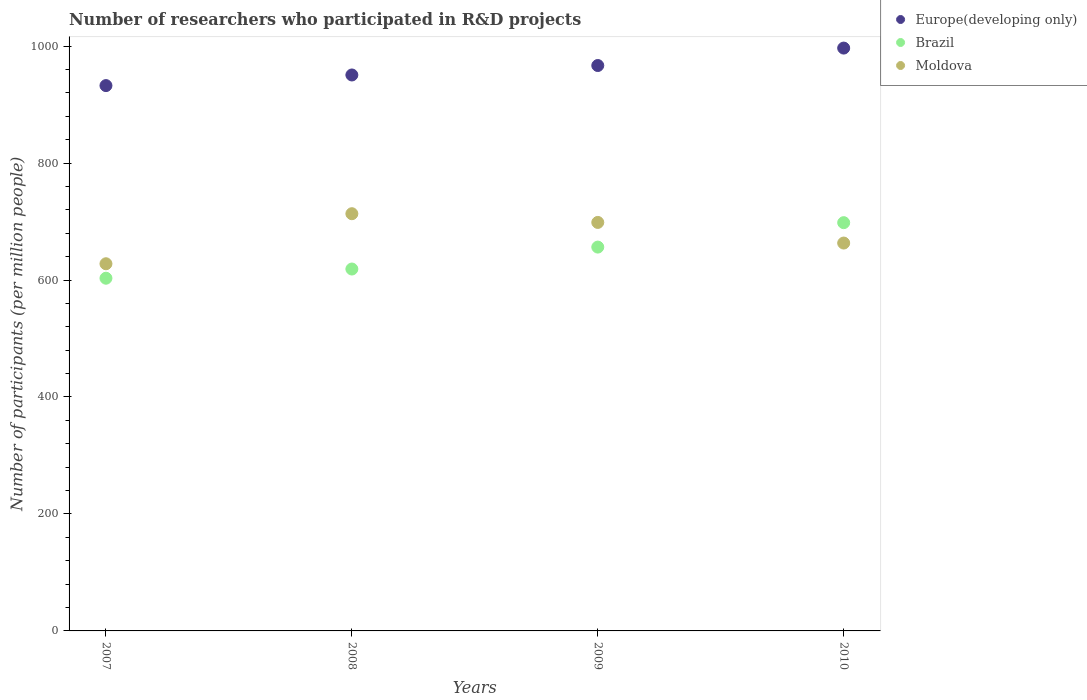How many different coloured dotlines are there?
Offer a terse response. 3. What is the number of researchers who participated in R&D projects in Europe(developing only) in 2008?
Your answer should be very brief. 950.66. Across all years, what is the maximum number of researchers who participated in R&D projects in Moldova?
Provide a short and direct response. 713.42. Across all years, what is the minimum number of researchers who participated in R&D projects in Europe(developing only)?
Keep it short and to the point. 932.49. In which year was the number of researchers who participated in R&D projects in Brazil maximum?
Keep it short and to the point. 2010. In which year was the number of researchers who participated in R&D projects in Moldova minimum?
Give a very brief answer. 2007. What is the total number of researchers who participated in R&D projects in Brazil in the graph?
Your response must be concise. 2576.37. What is the difference between the number of researchers who participated in R&D projects in Europe(developing only) in 2009 and that in 2010?
Provide a short and direct response. -29.82. What is the difference between the number of researchers who participated in R&D projects in Brazil in 2007 and the number of researchers who participated in R&D projects in Europe(developing only) in 2009?
Offer a terse response. -363.71. What is the average number of researchers who participated in R&D projects in Moldova per year?
Offer a terse response. 675.75. In the year 2008, what is the difference between the number of researchers who participated in R&D projects in Europe(developing only) and number of researchers who participated in R&D projects in Moldova?
Ensure brevity in your answer.  237.24. In how many years, is the number of researchers who participated in R&D projects in Brazil greater than 880?
Provide a succinct answer. 0. What is the ratio of the number of researchers who participated in R&D projects in Moldova in 2007 to that in 2009?
Give a very brief answer. 0.9. Is the number of researchers who participated in R&D projects in Europe(developing only) in 2008 less than that in 2010?
Your answer should be very brief. Yes. What is the difference between the highest and the second highest number of researchers who participated in R&D projects in Moldova?
Provide a succinct answer. 14.9. What is the difference between the highest and the lowest number of researchers who participated in R&D projects in Moldova?
Keep it short and to the point. 85.59. Is the sum of the number of researchers who participated in R&D projects in Europe(developing only) in 2009 and 2010 greater than the maximum number of researchers who participated in R&D projects in Moldova across all years?
Provide a short and direct response. Yes. Is it the case that in every year, the sum of the number of researchers who participated in R&D projects in Brazil and number of researchers who participated in R&D projects in Moldova  is greater than the number of researchers who participated in R&D projects in Europe(developing only)?
Keep it short and to the point. Yes. Does the number of researchers who participated in R&D projects in Moldova monotonically increase over the years?
Provide a succinct answer. No. Is the number of researchers who participated in R&D projects in Moldova strictly less than the number of researchers who participated in R&D projects in Brazil over the years?
Provide a succinct answer. No. How many dotlines are there?
Provide a succinct answer. 3. Are the values on the major ticks of Y-axis written in scientific E-notation?
Ensure brevity in your answer.  No. Does the graph contain grids?
Ensure brevity in your answer.  No. Where does the legend appear in the graph?
Give a very brief answer. Top right. How are the legend labels stacked?
Offer a very short reply. Vertical. What is the title of the graph?
Keep it short and to the point. Number of researchers who participated in R&D projects. Does "Ghana" appear as one of the legend labels in the graph?
Make the answer very short. No. What is the label or title of the X-axis?
Provide a succinct answer. Years. What is the label or title of the Y-axis?
Offer a terse response. Number of participants (per million people). What is the Number of participants (per million people) in Europe(developing only) in 2007?
Offer a very short reply. 932.49. What is the Number of participants (per million people) of Brazil in 2007?
Give a very brief answer. 603.11. What is the Number of participants (per million people) in Moldova in 2007?
Give a very brief answer. 627.84. What is the Number of participants (per million people) in Europe(developing only) in 2008?
Provide a succinct answer. 950.66. What is the Number of participants (per million people) of Brazil in 2008?
Your answer should be very brief. 618.83. What is the Number of participants (per million people) of Moldova in 2008?
Your response must be concise. 713.42. What is the Number of participants (per million people) of Europe(developing only) in 2009?
Make the answer very short. 966.82. What is the Number of participants (per million people) of Brazil in 2009?
Your response must be concise. 656.34. What is the Number of participants (per million people) in Moldova in 2009?
Your answer should be compact. 698.52. What is the Number of participants (per million people) in Europe(developing only) in 2010?
Make the answer very short. 996.64. What is the Number of participants (per million people) of Brazil in 2010?
Your answer should be compact. 698.1. What is the Number of participants (per million people) of Moldova in 2010?
Give a very brief answer. 663.24. Across all years, what is the maximum Number of participants (per million people) in Europe(developing only)?
Provide a succinct answer. 996.64. Across all years, what is the maximum Number of participants (per million people) in Brazil?
Make the answer very short. 698.1. Across all years, what is the maximum Number of participants (per million people) of Moldova?
Provide a succinct answer. 713.42. Across all years, what is the minimum Number of participants (per million people) of Europe(developing only)?
Your answer should be very brief. 932.49. Across all years, what is the minimum Number of participants (per million people) in Brazil?
Give a very brief answer. 603.11. Across all years, what is the minimum Number of participants (per million people) of Moldova?
Your answer should be very brief. 627.84. What is the total Number of participants (per million people) in Europe(developing only) in the graph?
Ensure brevity in your answer.  3846.61. What is the total Number of participants (per million people) in Brazil in the graph?
Offer a very short reply. 2576.37. What is the total Number of participants (per million people) of Moldova in the graph?
Provide a succinct answer. 2703.02. What is the difference between the Number of participants (per million people) of Europe(developing only) in 2007 and that in 2008?
Give a very brief answer. -18.17. What is the difference between the Number of participants (per million people) of Brazil in 2007 and that in 2008?
Offer a very short reply. -15.72. What is the difference between the Number of participants (per million people) in Moldova in 2007 and that in 2008?
Your answer should be compact. -85.59. What is the difference between the Number of participants (per million people) of Europe(developing only) in 2007 and that in 2009?
Give a very brief answer. -34.33. What is the difference between the Number of participants (per million people) in Brazil in 2007 and that in 2009?
Keep it short and to the point. -53.23. What is the difference between the Number of participants (per million people) of Moldova in 2007 and that in 2009?
Keep it short and to the point. -70.68. What is the difference between the Number of participants (per million people) in Europe(developing only) in 2007 and that in 2010?
Provide a succinct answer. -64.15. What is the difference between the Number of participants (per million people) of Brazil in 2007 and that in 2010?
Offer a very short reply. -94.99. What is the difference between the Number of participants (per million people) in Moldova in 2007 and that in 2010?
Offer a very short reply. -35.4. What is the difference between the Number of participants (per million people) in Europe(developing only) in 2008 and that in 2009?
Your response must be concise. -16.16. What is the difference between the Number of participants (per million people) in Brazil in 2008 and that in 2009?
Your response must be concise. -37.51. What is the difference between the Number of participants (per million people) in Moldova in 2008 and that in 2009?
Make the answer very short. 14.9. What is the difference between the Number of participants (per million people) in Europe(developing only) in 2008 and that in 2010?
Provide a succinct answer. -45.98. What is the difference between the Number of participants (per million people) of Brazil in 2008 and that in 2010?
Your answer should be compact. -79.27. What is the difference between the Number of participants (per million people) of Moldova in 2008 and that in 2010?
Make the answer very short. 50.18. What is the difference between the Number of participants (per million people) in Europe(developing only) in 2009 and that in 2010?
Provide a succinct answer. -29.82. What is the difference between the Number of participants (per million people) in Brazil in 2009 and that in 2010?
Keep it short and to the point. -41.77. What is the difference between the Number of participants (per million people) in Moldova in 2009 and that in 2010?
Your answer should be compact. 35.28. What is the difference between the Number of participants (per million people) in Europe(developing only) in 2007 and the Number of participants (per million people) in Brazil in 2008?
Your answer should be very brief. 313.66. What is the difference between the Number of participants (per million people) in Europe(developing only) in 2007 and the Number of participants (per million people) in Moldova in 2008?
Keep it short and to the point. 219.07. What is the difference between the Number of participants (per million people) in Brazil in 2007 and the Number of participants (per million people) in Moldova in 2008?
Give a very brief answer. -110.31. What is the difference between the Number of participants (per million people) of Europe(developing only) in 2007 and the Number of participants (per million people) of Brazil in 2009?
Make the answer very short. 276.15. What is the difference between the Number of participants (per million people) in Europe(developing only) in 2007 and the Number of participants (per million people) in Moldova in 2009?
Offer a very short reply. 233.97. What is the difference between the Number of participants (per million people) in Brazil in 2007 and the Number of participants (per million people) in Moldova in 2009?
Make the answer very short. -95.41. What is the difference between the Number of participants (per million people) of Europe(developing only) in 2007 and the Number of participants (per million people) of Brazil in 2010?
Offer a very short reply. 234.39. What is the difference between the Number of participants (per million people) in Europe(developing only) in 2007 and the Number of participants (per million people) in Moldova in 2010?
Provide a succinct answer. 269.25. What is the difference between the Number of participants (per million people) of Brazil in 2007 and the Number of participants (per million people) of Moldova in 2010?
Offer a terse response. -60.13. What is the difference between the Number of participants (per million people) in Europe(developing only) in 2008 and the Number of participants (per million people) in Brazil in 2009?
Provide a succinct answer. 294.32. What is the difference between the Number of participants (per million people) of Europe(developing only) in 2008 and the Number of participants (per million people) of Moldova in 2009?
Offer a terse response. 252.14. What is the difference between the Number of participants (per million people) of Brazil in 2008 and the Number of participants (per million people) of Moldova in 2009?
Your answer should be very brief. -79.69. What is the difference between the Number of participants (per million people) in Europe(developing only) in 2008 and the Number of participants (per million people) in Brazil in 2010?
Ensure brevity in your answer.  252.56. What is the difference between the Number of participants (per million people) in Europe(developing only) in 2008 and the Number of participants (per million people) in Moldova in 2010?
Make the answer very short. 287.42. What is the difference between the Number of participants (per million people) of Brazil in 2008 and the Number of participants (per million people) of Moldova in 2010?
Ensure brevity in your answer.  -44.41. What is the difference between the Number of participants (per million people) of Europe(developing only) in 2009 and the Number of participants (per million people) of Brazil in 2010?
Ensure brevity in your answer.  268.72. What is the difference between the Number of participants (per million people) in Europe(developing only) in 2009 and the Number of participants (per million people) in Moldova in 2010?
Provide a succinct answer. 303.58. What is the difference between the Number of participants (per million people) of Brazil in 2009 and the Number of participants (per million people) of Moldova in 2010?
Ensure brevity in your answer.  -6.91. What is the average Number of participants (per million people) of Europe(developing only) per year?
Offer a terse response. 961.65. What is the average Number of participants (per million people) of Brazil per year?
Your answer should be very brief. 644.09. What is the average Number of participants (per million people) in Moldova per year?
Keep it short and to the point. 675.75. In the year 2007, what is the difference between the Number of participants (per million people) of Europe(developing only) and Number of participants (per million people) of Brazil?
Provide a short and direct response. 329.38. In the year 2007, what is the difference between the Number of participants (per million people) in Europe(developing only) and Number of participants (per million people) in Moldova?
Make the answer very short. 304.65. In the year 2007, what is the difference between the Number of participants (per million people) in Brazil and Number of participants (per million people) in Moldova?
Your response must be concise. -24.73. In the year 2008, what is the difference between the Number of participants (per million people) in Europe(developing only) and Number of participants (per million people) in Brazil?
Offer a very short reply. 331.83. In the year 2008, what is the difference between the Number of participants (per million people) in Europe(developing only) and Number of participants (per million people) in Moldova?
Offer a terse response. 237.24. In the year 2008, what is the difference between the Number of participants (per million people) in Brazil and Number of participants (per million people) in Moldova?
Offer a very short reply. -94.59. In the year 2009, what is the difference between the Number of participants (per million people) in Europe(developing only) and Number of participants (per million people) in Brazil?
Your response must be concise. 310.48. In the year 2009, what is the difference between the Number of participants (per million people) of Europe(developing only) and Number of participants (per million people) of Moldova?
Your answer should be very brief. 268.3. In the year 2009, what is the difference between the Number of participants (per million people) of Brazil and Number of participants (per million people) of Moldova?
Provide a short and direct response. -42.18. In the year 2010, what is the difference between the Number of participants (per million people) in Europe(developing only) and Number of participants (per million people) in Brazil?
Keep it short and to the point. 298.54. In the year 2010, what is the difference between the Number of participants (per million people) in Europe(developing only) and Number of participants (per million people) in Moldova?
Your answer should be compact. 333.4. In the year 2010, what is the difference between the Number of participants (per million people) in Brazil and Number of participants (per million people) in Moldova?
Your answer should be compact. 34.86. What is the ratio of the Number of participants (per million people) in Europe(developing only) in 2007 to that in 2008?
Give a very brief answer. 0.98. What is the ratio of the Number of participants (per million people) of Brazil in 2007 to that in 2008?
Make the answer very short. 0.97. What is the ratio of the Number of participants (per million people) of Europe(developing only) in 2007 to that in 2009?
Keep it short and to the point. 0.96. What is the ratio of the Number of participants (per million people) in Brazil in 2007 to that in 2009?
Your answer should be compact. 0.92. What is the ratio of the Number of participants (per million people) in Moldova in 2007 to that in 2009?
Ensure brevity in your answer.  0.9. What is the ratio of the Number of participants (per million people) in Europe(developing only) in 2007 to that in 2010?
Offer a terse response. 0.94. What is the ratio of the Number of participants (per million people) of Brazil in 2007 to that in 2010?
Give a very brief answer. 0.86. What is the ratio of the Number of participants (per million people) of Moldova in 2007 to that in 2010?
Give a very brief answer. 0.95. What is the ratio of the Number of participants (per million people) in Europe(developing only) in 2008 to that in 2009?
Provide a succinct answer. 0.98. What is the ratio of the Number of participants (per million people) in Brazil in 2008 to that in 2009?
Your response must be concise. 0.94. What is the ratio of the Number of participants (per million people) in Moldova in 2008 to that in 2009?
Offer a very short reply. 1.02. What is the ratio of the Number of participants (per million people) of Europe(developing only) in 2008 to that in 2010?
Give a very brief answer. 0.95. What is the ratio of the Number of participants (per million people) in Brazil in 2008 to that in 2010?
Ensure brevity in your answer.  0.89. What is the ratio of the Number of participants (per million people) in Moldova in 2008 to that in 2010?
Give a very brief answer. 1.08. What is the ratio of the Number of participants (per million people) of Europe(developing only) in 2009 to that in 2010?
Offer a terse response. 0.97. What is the ratio of the Number of participants (per million people) in Brazil in 2009 to that in 2010?
Give a very brief answer. 0.94. What is the ratio of the Number of participants (per million people) in Moldova in 2009 to that in 2010?
Offer a very short reply. 1.05. What is the difference between the highest and the second highest Number of participants (per million people) in Europe(developing only)?
Your answer should be compact. 29.82. What is the difference between the highest and the second highest Number of participants (per million people) in Brazil?
Your answer should be very brief. 41.77. What is the difference between the highest and the second highest Number of participants (per million people) in Moldova?
Your answer should be very brief. 14.9. What is the difference between the highest and the lowest Number of participants (per million people) in Europe(developing only)?
Provide a short and direct response. 64.15. What is the difference between the highest and the lowest Number of participants (per million people) of Brazil?
Offer a very short reply. 94.99. What is the difference between the highest and the lowest Number of participants (per million people) in Moldova?
Give a very brief answer. 85.59. 